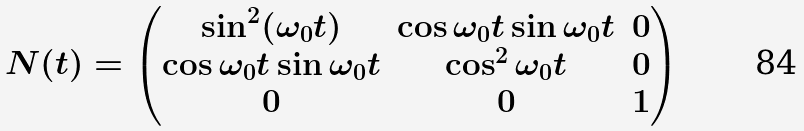Convert formula to latex. <formula><loc_0><loc_0><loc_500><loc_500>N ( t ) = \left ( \begin{matrix} \sin ^ { 2 } ( \omega _ { 0 } t ) & \cos \omega _ { 0 } t \sin \omega _ { 0 } t & 0 \\ \cos \omega _ { 0 } t \sin \omega _ { 0 } t & \cos ^ { 2 } \omega _ { 0 } t & 0 \\ 0 & 0 & 1 \end{matrix} \right )</formula> 